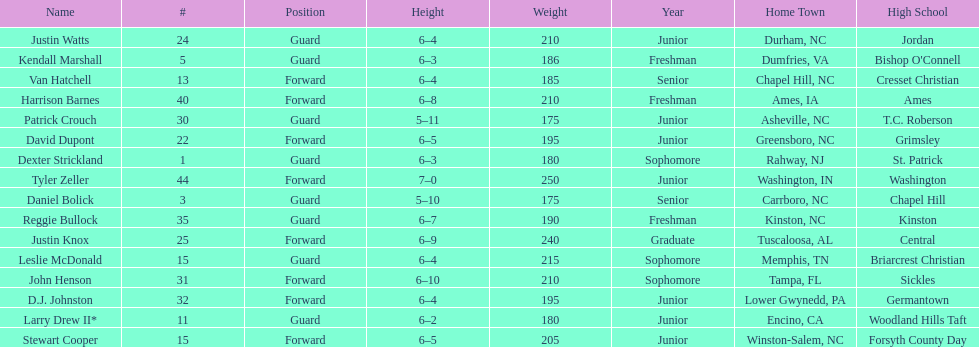How many players are not a junior? 9. 